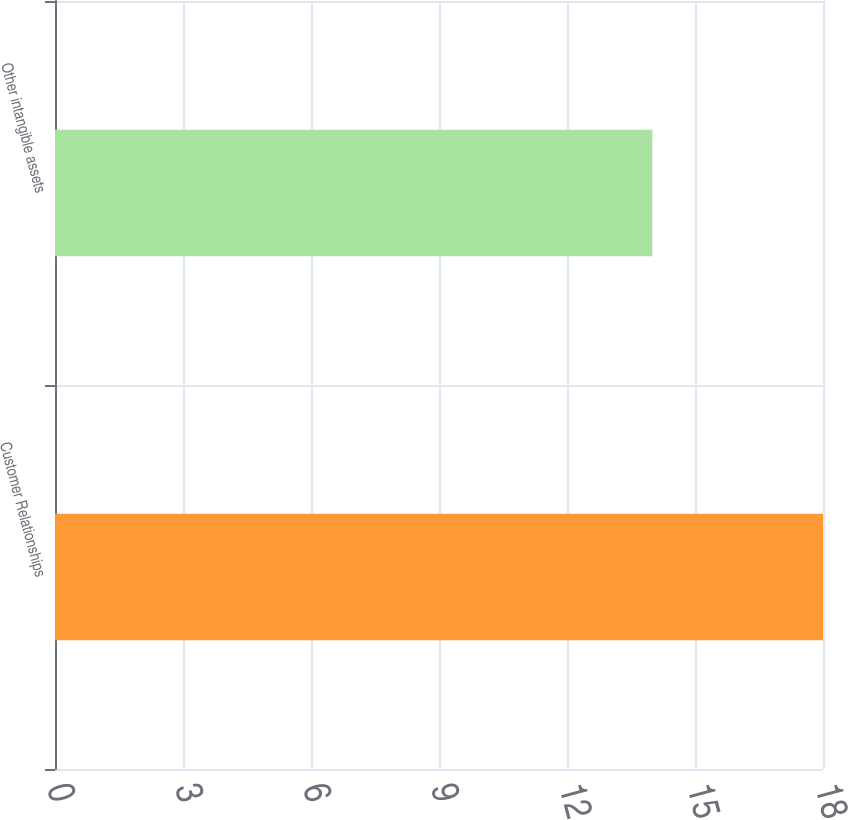Convert chart to OTSL. <chart><loc_0><loc_0><loc_500><loc_500><bar_chart><fcel>Customer Relationships<fcel>Other intangible assets<nl><fcel>18<fcel>14<nl></chart> 